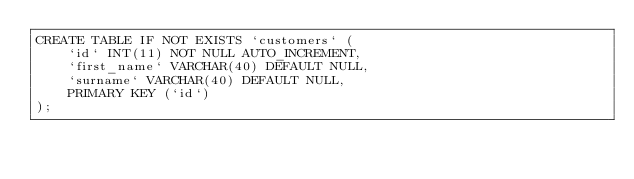<code> <loc_0><loc_0><loc_500><loc_500><_SQL_>CREATE TABLE IF NOT EXISTS `customers` (
    `id` INT(11) NOT NULL AUTO_INCREMENT,
    `first_name` VARCHAR(40) DEFAULT NULL,
    `surname` VARCHAR(40) DEFAULT NULL,
    PRIMARY KEY (`id`)
);</code> 